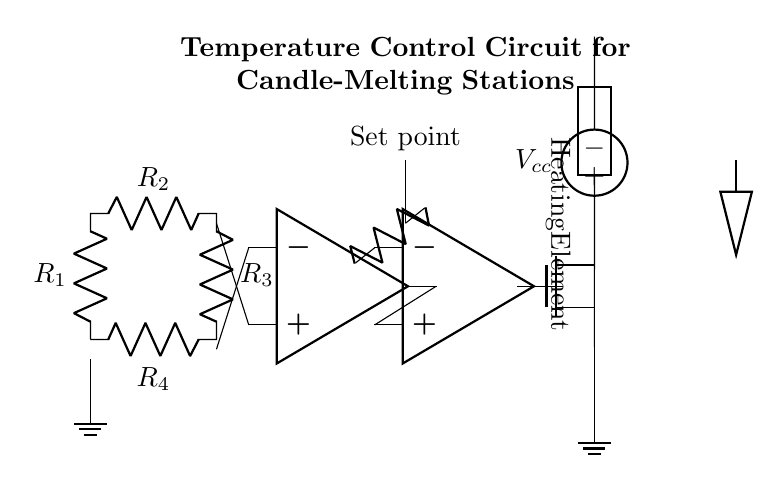What type of sensor is used in this circuit? The circuit includes a thermistor, which is a type of temperature sensor. It is shown at the beginning of the diagram.
Answer: Thermistor What is the purpose of the operational amplifier in this circuit? The operational amplifier is configured as a comparator, which compares the output from the Wheatstone bridge with a reference voltage (set point). This function is pivotal for regulating the temperature.
Answer: Comparator What is the function of the MOSFET in this circuit? The MOSFET acts as a switch that controls the power to the heating element based on the signal received from the operational amplifier. When the comparator output triggers it, the MOSFET allows current to flow to the heating element.
Answer: Switch How many resistors are in the Wheatstone bridge? There are four resistors in the Wheatstone bridge configuration, labeled as R1, R2, R3, and R4 in the diagram.
Answer: Four What is the voltage source labeled as in the circuit? The voltage source providing power to the heating element is labeled as Vcc, indicating the supply voltage for the circuit.
Answer: Vcc Why is the set point important in the circuit? The set point, marked in the diagram, is the reference temperature that the circuit aims to maintain. The operational amplifier uses this value to determine if additional heating is required to reach the desired temperature.
Answer: Reference temperature What type of load is represented by the heating element? The heating element is represented as a generic load in the circuit diagram, which indicates that it can consume power for heating. It is critical for melting the candle.
Answer: Generic load 